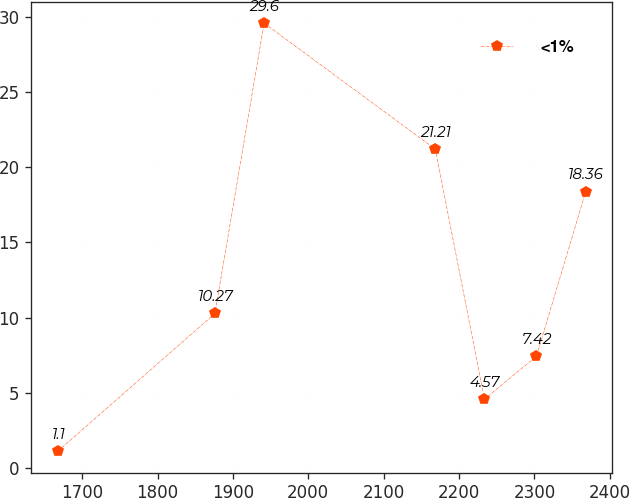<chart> <loc_0><loc_0><loc_500><loc_500><line_chart><ecel><fcel><1%<nl><fcel>1667.68<fcel>1.1<nl><fcel>1876.19<fcel>10.27<nl><fcel>1941.4<fcel>29.6<nl><fcel>2168.54<fcel>21.21<nl><fcel>2233.75<fcel>4.57<nl><fcel>2302.73<fcel>7.42<nl><fcel>2367.94<fcel>18.36<nl></chart> 